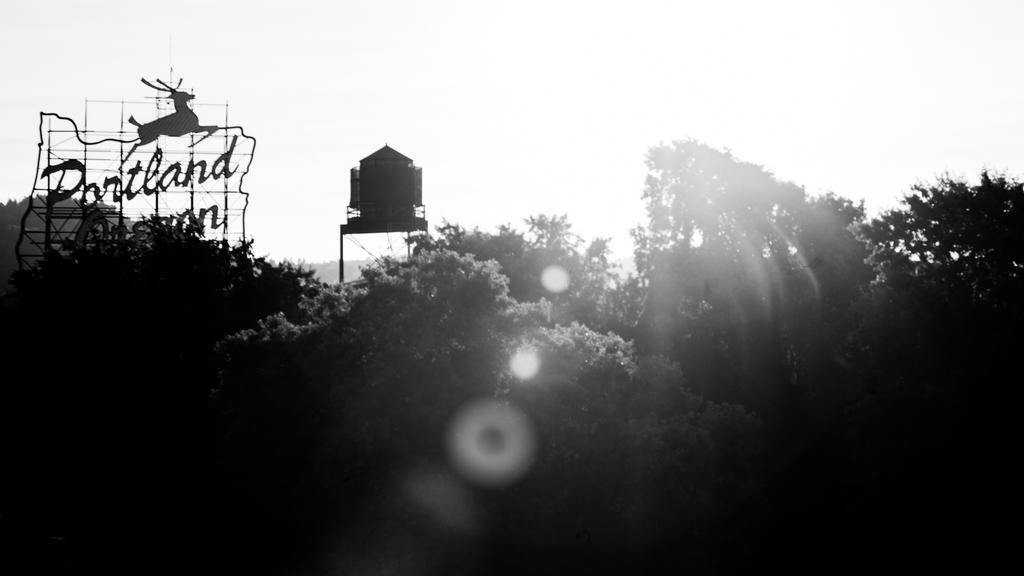Please provide a concise description of this image. In this image I can see few trees,water tank and a board. I can see an animal image and something is written on it. The image is in black and white. 